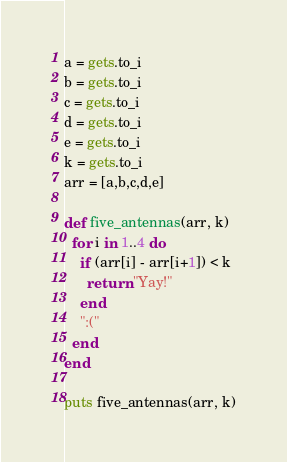Convert code to text. <code><loc_0><loc_0><loc_500><loc_500><_Ruby_>a = gets.to_i
b = gets.to_i
c = gets.to_i
d = gets.to_i
e = gets.to_i
k = gets.to_i
arr = [a,b,c,d,e]

def five_antennas(arr, k)
  for i in 1..4 do
    if (arr[i] - arr[i+1]) < k
      return "Yay!"
    end
    ":("
  end
end

puts five_antennas(arr, k)
</code> 